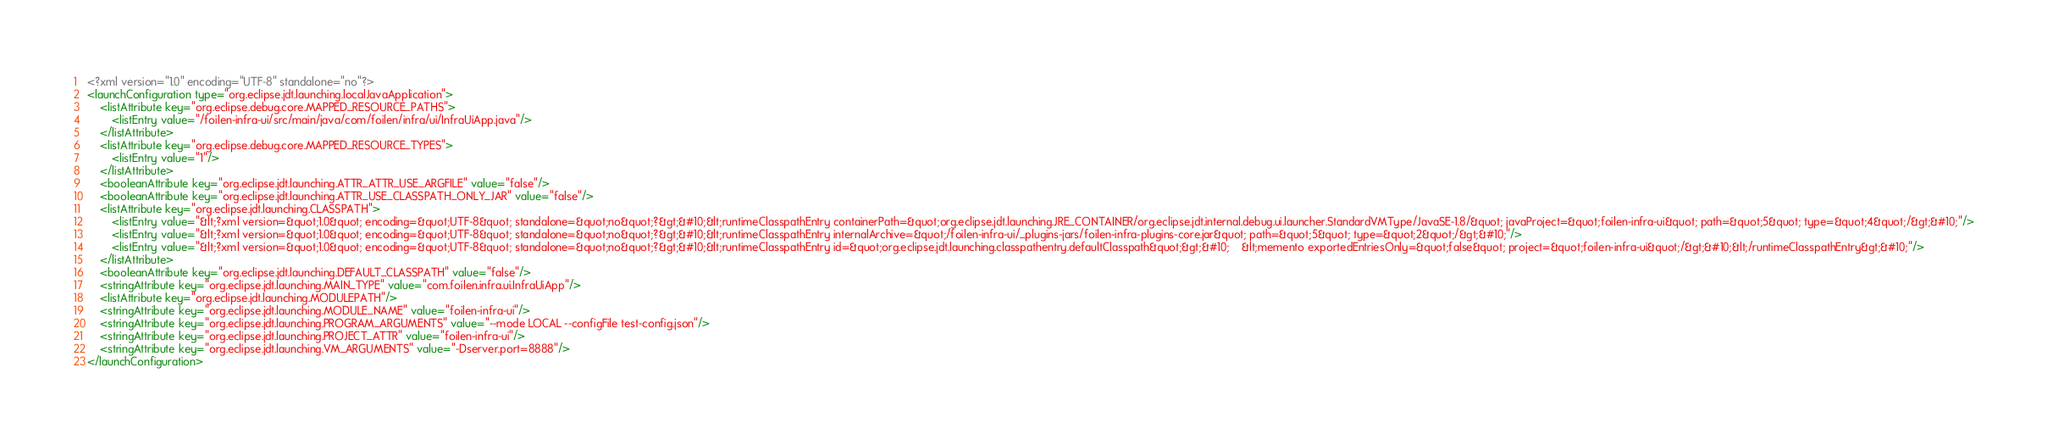Convert code to text. <code><loc_0><loc_0><loc_500><loc_500><_XML_><?xml version="1.0" encoding="UTF-8" standalone="no"?>
<launchConfiguration type="org.eclipse.jdt.launching.localJavaApplication">
    <listAttribute key="org.eclipse.debug.core.MAPPED_RESOURCE_PATHS">
        <listEntry value="/foilen-infra-ui/src/main/java/com/foilen/infra/ui/InfraUiApp.java"/>
    </listAttribute>
    <listAttribute key="org.eclipse.debug.core.MAPPED_RESOURCE_TYPES">
        <listEntry value="1"/>
    </listAttribute>
    <booleanAttribute key="org.eclipse.jdt.launching.ATTR_ATTR_USE_ARGFILE" value="false"/>
    <booleanAttribute key="org.eclipse.jdt.launching.ATTR_USE_CLASSPATH_ONLY_JAR" value="false"/>
    <listAttribute key="org.eclipse.jdt.launching.CLASSPATH">
        <listEntry value="&lt;?xml version=&quot;1.0&quot; encoding=&quot;UTF-8&quot; standalone=&quot;no&quot;?&gt;&#10;&lt;runtimeClasspathEntry containerPath=&quot;org.eclipse.jdt.launching.JRE_CONTAINER/org.eclipse.jdt.internal.debug.ui.launcher.StandardVMType/JavaSE-1.8/&quot; javaProject=&quot;foilen-infra-ui&quot; path=&quot;5&quot; type=&quot;4&quot;/&gt;&#10;"/>
        <listEntry value="&lt;?xml version=&quot;1.0&quot; encoding=&quot;UTF-8&quot; standalone=&quot;no&quot;?&gt;&#10;&lt;runtimeClasspathEntry internalArchive=&quot;/foilen-infra-ui/_plugins-jars/foilen-infra-plugins-core.jar&quot; path=&quot;5&quot; type=&quot;2&quot;/&gt;&#10;"/>
        <listEntry value="&lt;?xml version=&quot;1.0&quot; encoding=&quot;UTF-8&quot; standalone=&quot;no&quot;?&gt;&#10;&lt;runtimeClasspathEntry id=&quot;org.eclipse.jdt.launching.classpathentry.defaultClasspath&quot;&gt;&#10;    &lt;memento exportedEntriesOnly=&quot;false&quot; project=&quot;foilen-infra-ui&quot;/&gt;&#10;&lt;/runtimeClasspathEntry&gt;&#10;"/>
    </listAttribute>
    <booleanAttribute key="org.eclipse.jdt.launching.DEFAULT_CLASSPATH" value="false"/>
    <stringAttribute key="org.eclipse.jdt.launching.MAIN_TYPE" value="com.foilen.infra.ui.InfraUiApp"/>
    <listAttribute key="org.eclipse.jdt.launching.MODULEPATH"/>
    <stringAttribute key="org.eclipse.jdt.launching.MODULE_NAME" value="foilen-infra-ui"/>
    <stringAttribute key="org.eclipse.jdt.launching.PROGRAM_ARGUMENTS" value="--mode LOCAL --configFile test-config.json"/>
    <stringAttribute key="org.eclipse.jdt.launching.PROJECT_ATTR" value="foilen-infra-ui"/>
    <stringAttribute key="org.eclipse.jdt.launching.VM_ARGUMENTS" value="-Dserver.port=8888"/>
</launchConfiguration>
</code> 